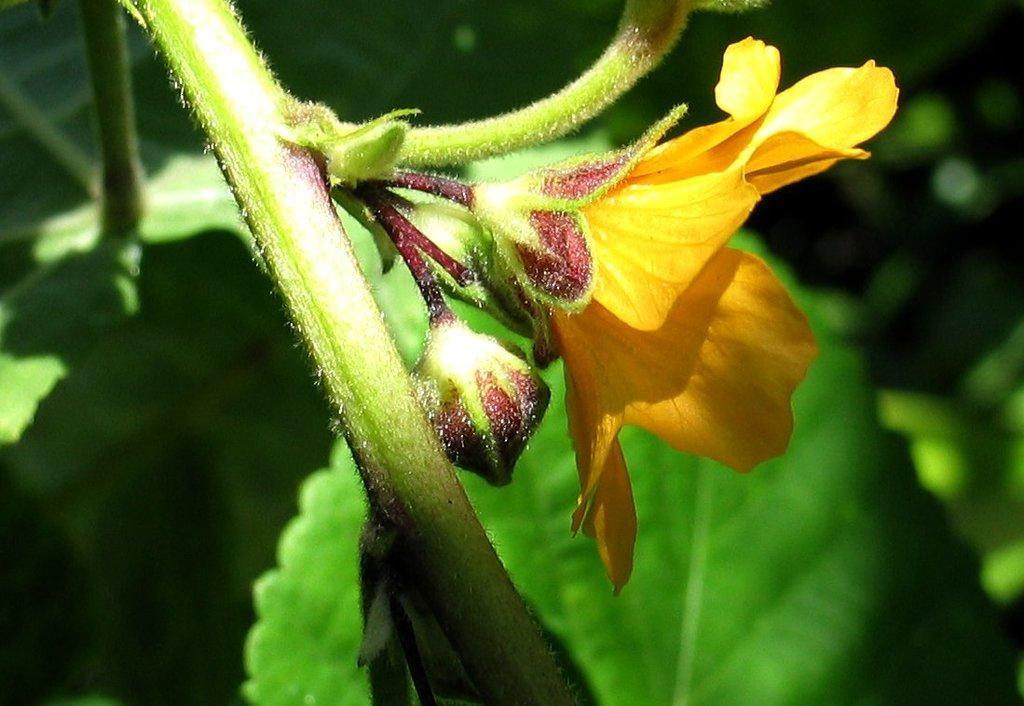Could you give a brief overview of what you see in this image? There is a zoom in picture of a stem with some flowers as we can see in the middle of this image. 